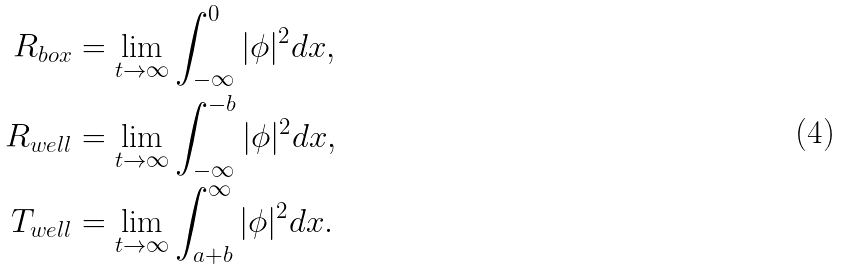Convert formula to latex. <formula><loc_0><loc_0><loc_500><loc_500>R _ { b o x } & = \lim _ { t \rightarrow \infty } \int _ { - \infty } ^ { 0 } | \phi | ^ { 2 } d x , \\ R _ { w e l l } & = \lim _ { t \rightarrow \infty } \int _ { - \infty } ^ { - b } | \phi | ^ { 2 } d x , \\ T _ { w e l l } & = \lim _ { t \rightarrow \infty } \int _ { a + b } ^ { \infty } | \phi | ^ { 2 } d x .</formula> 